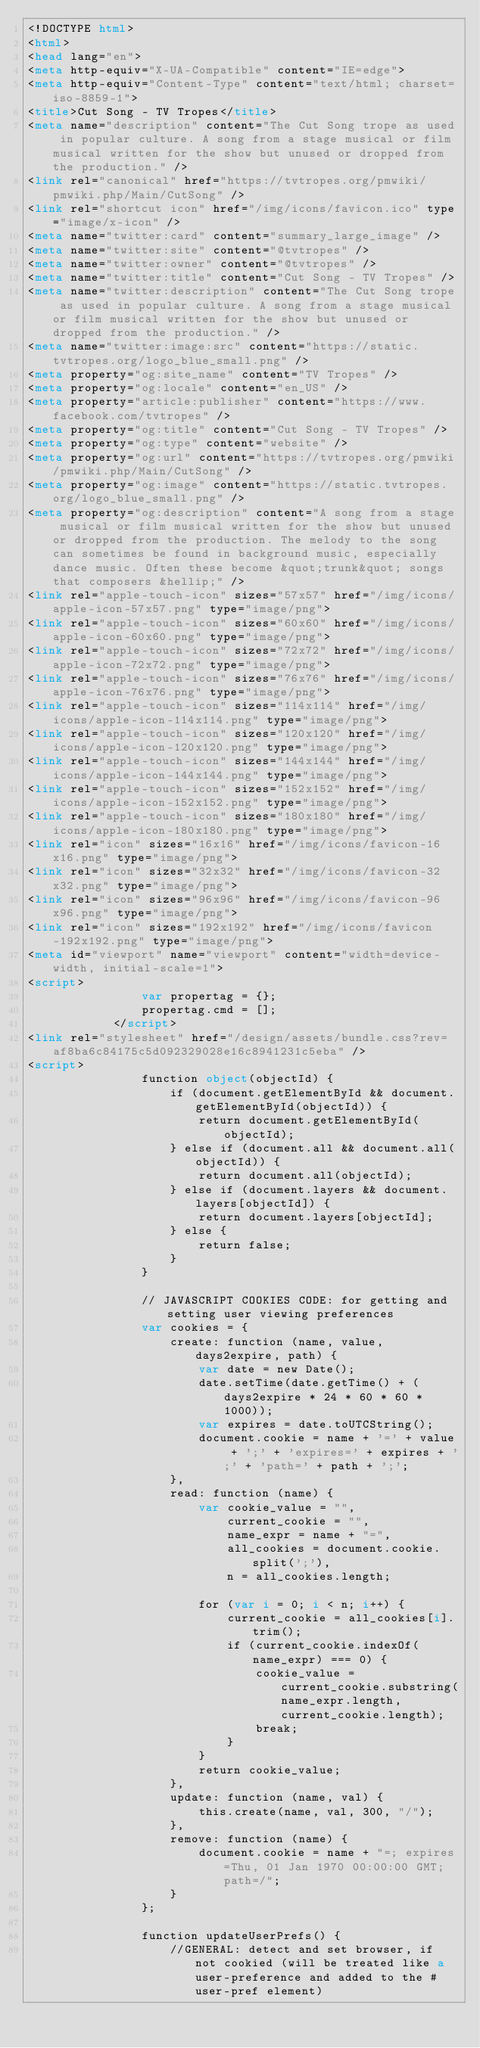<code> <loc_0><loc_0><loc_500><loc_500><_HTML_><!DOCTYPE html>
<html>
<head lang="en">
<meta http-equiv="X-UA-Compatible" content="IE=edge">
<meta http-equiv="Content-Type" content="text/html; charset=iso-8859-1">
<title>Cut Song - TV Tropes</title>
<meta name="description" content="The Cut Song trope as used in popular culture. A song from a stage musical or film musical written for the show but unused or dropped from the production." />
<link rel="canonical" href="https://tvtropes.org/pmwiki/pmwiki.php/Main/CutSong" />
<link rel="shortcut icon" href="/img/icons/favicon.ico" type="image/x-icon" />
<meta name="twitter:card" content="summary_large_image" />
<meta name="twitter:site" content="@tvtropes" />
<meta name="twitter:owner" content="@tvtropes" />
<meta name="twitter:title" content="Cut Song - TV Tropes" />
<meta name="twitter:description" content="The Cut Song trope as used in popular culture. A song from a stage musical or film musical written for the show but unused or dropped from the production." />
<meta name="twitter:image:src" content="https://static.tvtropes.org/logo_blue_small.png" />
<meta property="og:site_name" content="TV Tropes" />
<meta property="og:locale" content="en_US" />
<meta property="article:publisher" content="https://www.facebook.com/tvtropes" />
<meta property="og:title" content="Cut Song - TV Tropes" />
<meta property="og:type" content="website" />
<meta property="og:url" content="https://tvtropes.org/pmwiki/pmwiki.php/Main/CutSong" />
<meta property="og:image" content="https://static.tvtropes.org/logo_blue_small.png" />
<meta property="og:description" content="A song from a stage musical or film musical written for the show but unused or dropped from the production. The melody to the song can sometimes be found in background music, especially dance music. Often these become &quot;trunk&quot; songs that composers &hellip;" />
<link rel="apple-touch-icon" sizes="57x57" href="/img/icons/apple-icon-57x57.png" type="image/png">
<link rel="apple-touch-icon" sizes="60x60" href="/img/icons/apple-icon-60x60.png" type="image/png">
<link rel="apple-touch-icon" sizes="72x72" href="/img/icons/apple-icon-72x72.png" type="image/png">
<link rel="apple-touch-icon" sizes="76x76" href="/img/icons/apple-icon-76x76.png" type="image/png">
<link rel="apple-touch-icon" sizes="114x114" href="/img/icons/apple-icon-114x114.png" type="image/png">
<link rel="apple-touch-icon" sizes="120x120" href="/img/icons/apple-icon-120x120.png" type="image/png">
<link rel="apple-touch-icon" sizes="144x144" href="/img/icons/apple-icon-144x144.png" type="image/png">
<link rel="apple-touch-icon" sizes="152x152" href="/img/icons/apple-icon-152x152.png" type="image/png">
<link rel="apple-touch-icon" sizes="180x180" href="/img/icons/apple-icon-180x180.png" type="image/png">
<link rel="icon" sizes="16x16" href="/img/icons/favicon-16x16.png" type="image/png">
<link rel="icon" sizes="32x32" href="/img/icons/favicon-32x32.png" type="image/png">
<link rel="icon" sizes="96x96" href="/img/icons/favicon-96x96.png" type="image/png">
<link rel="icon" sizes="192x192" href="/img/icons/favicon-192x192.png" type="image/png">
<meta id="viewport" name="viewport" content="width=device-width, initial-scale=1">
<script>
                var propertag = {};
                propertag.cmd = [];
            </script>
<link rel="stylesheet" href="/design/assets/bundle.css?rev=af8ba6c84175c5d092329028e16c8941231c5eba" />
<script>
                function object(objectId) {
                    if (document.getElementById && document.getElementById(objectId)) {
                        return document.getElementById(objectId);
                    } else if (document.all && document.all(objectId)) {
                        return document.all(objectId);
                    } else if (document.layers && document.layers[objectId]) {
                        return document.layers[objectId];
                    } else {
                        return false;
                    }
                }

                // JAVASCRIPT COOKIES CODE: for getting and setting user viewing preferences
                var cookies = {
                    create: function (name, value, days2expire, path) {
                        var date = new Date();
                        date.setTime(date.getTime() + (days2expire * 24 * 60 * 60 * 1000));
                        var expires = date.toUTCString();
                        document.cookie = name + '=' + value + ';' + 'expires=' + expires + ';' + 'path=' + path + ';';
                    },
                    read: function (name) {
                        var cookie_value = "",
                            current_cookie = "",
                            name_expr = name + "=",
                            all_cookies = document.cookie.split(';'),
                            n = all_cookies.length;

                        for (var i = 0; i < n; i++) {
                            current_cookie = all_cookies[i].trim();
                            if (current_cookie.indexOf(name_expr) === 0) {
                                cookie_value = current_cookie.substring(name_expr.length, current_cookie.length);
                                break;
                            }
                        }
                        return cookie_value;
                    },
                    update: function (name, val) {
                        this.create(name, val, 300, "/");
                    },
                    remove: function (name) {
                        document.cookie = name + "=; expires=Thu, 01 Jan 1970 00:00:00 GMT; path=/";
                    }
                };

                function updateUserPrefs() {
                    //GENERAL: detect and set browser, if not cookied (will be treated like a user-preference and added to the #user-pref element)</code> 